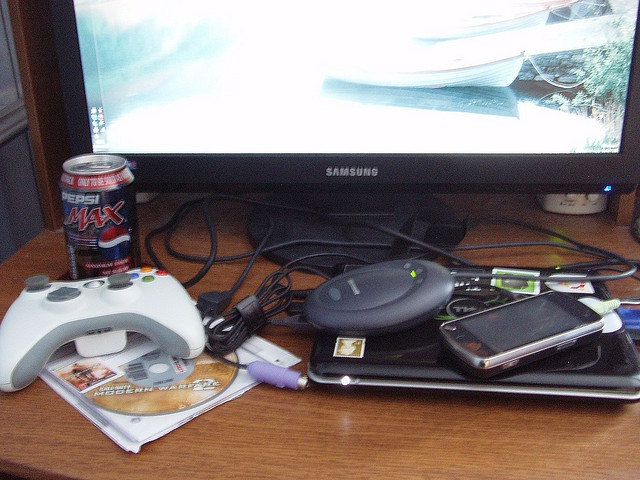Describe the objects in this image and their specific colors. I can see tv in purple, white, black, lightblue, and gray tones, laptop in purple, black, gray, lightgray, and darkgray tones, cell phone in purple, gray, black, and darkgray tones, and mouse in purple, gray, black, and darkblue tones in this image. 